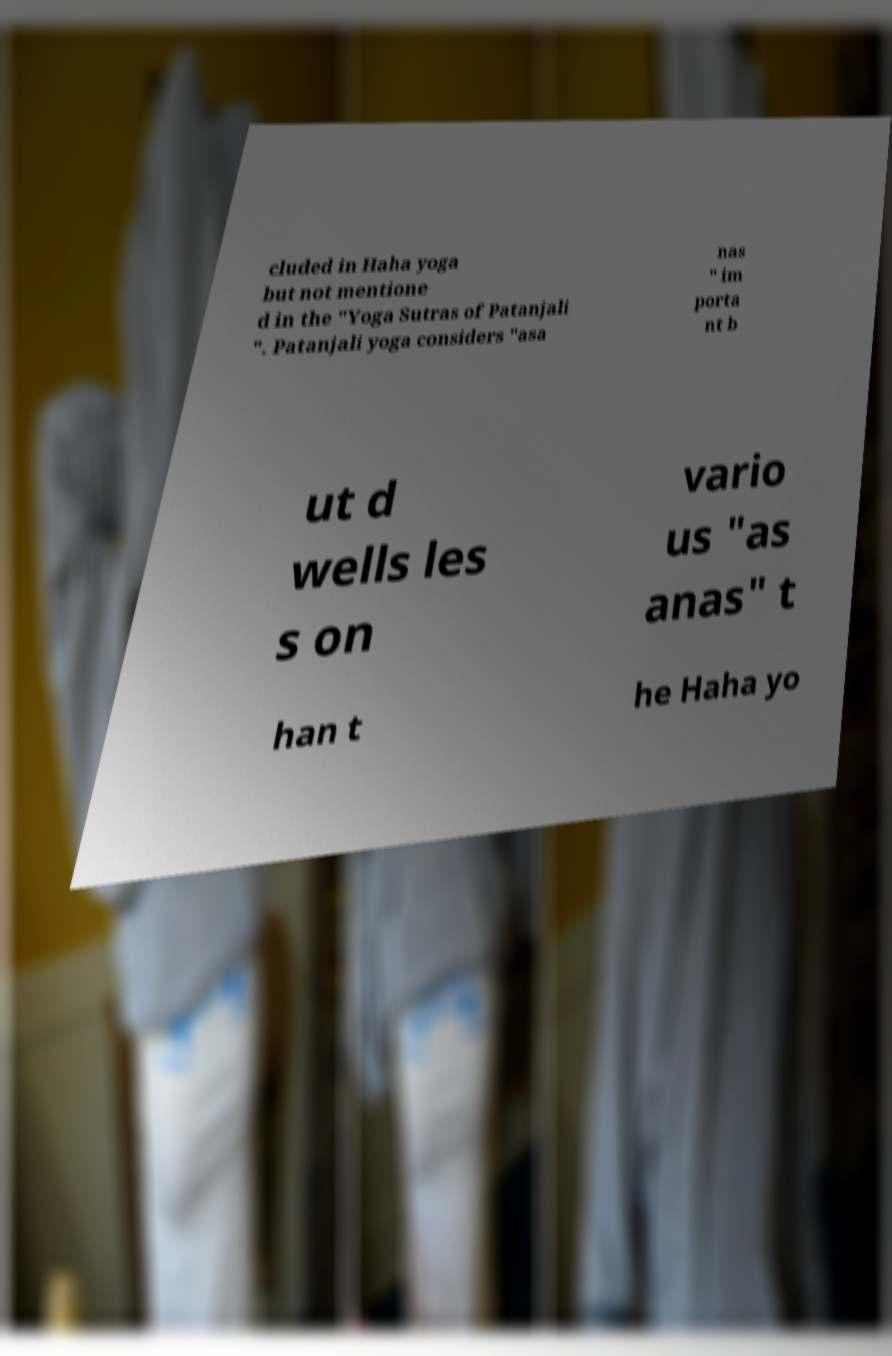Can you read and provide the text displayed in the image?This photo seems to have some interesting text. Can you extract and type it out for me? cluded in Haha yoga but not mentione d in the "Yoga Sutras of Patanjali ". Patanjali yoga considers "asa nas " im porta nt b ut d wells les s on vario us "as anas" t han t he Haha yo 